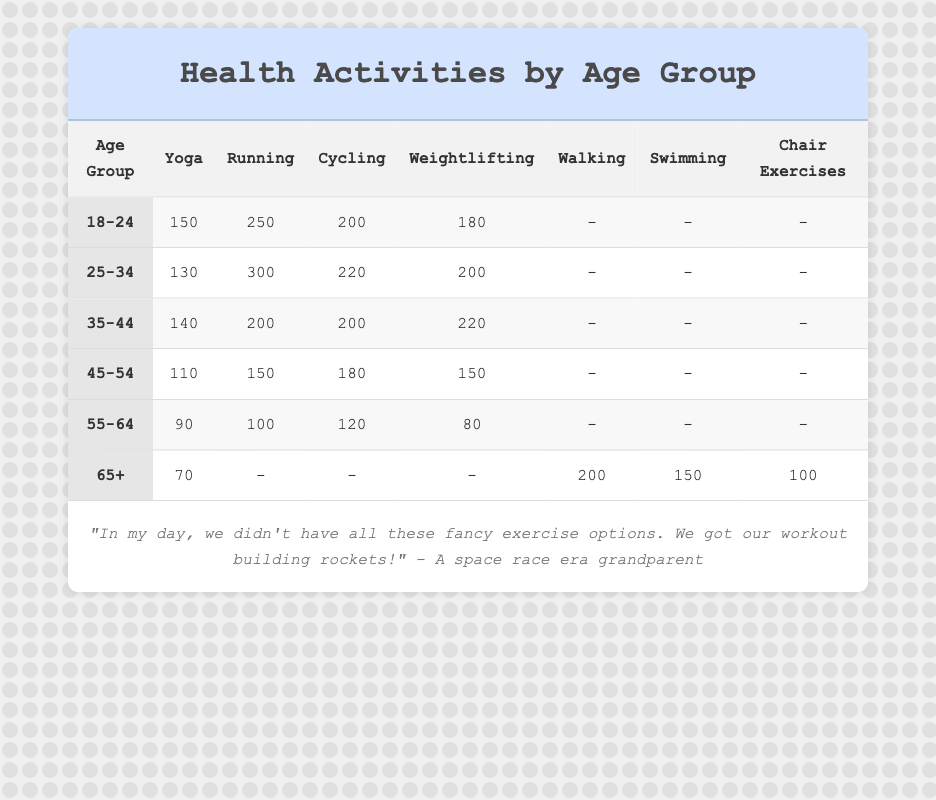What is the preferred exercise type for the age group 25-34? The table shows that the preferred exercise type for the age group 25-34 is Running, with a total of 300 people participating in it.
Answer: Running How many people in the 65+ age group prefer Swimming? From the table, it is clear that the number of people in the 65+ age group who prefer Swimming is 150.
Answer: 150 Which age group has the highest participation in Weightlifting? Examining the Weightlifting column, the age group 35-44 shows the highest participation with 220 individuals.
Answer: 35-44 What is the total number of individuals who prefer Yoga across all age groups? To find the total, we sum the participation in Yoga from all age groups: 150 + 130 + 140 + 110 + 90 + 70 = 690. Thus, the total number of individuals who prefer Yoga is 690.
Answer: 690 Is it true that more people in the age group 55-64 prefer Running than Yoga? In the table, the number of people in the age group 55-64 who prefer Running is 100, while for Yoga it is 90. Therefore, it is true that more people in this age group prefer Running than Yoga.
Answer: Yes What is the difference between the number of individuals who prefer Cycling in the 18-24 and 45-54 age groups? The number of individuals preferring Cycling in the 18-24 age group is 200, while in the 45-54 age group it is 180. The difference is calculated as 200 - 180 = 20. Hence, the difference is 20.
Answer: 20 Which age group has the least participation in Weightlifting and what is the number? Reviewing the Weightlifting column, the age group with the least participation in Weightlifting is 55-64 with a total of 80.
Answer: 55-64, 80 What is the average number of people who prefer Walking among those aged 65 and above? In the age group 65+, there is only one value for Walking, which is 200. Since there is only one data point, the average for Walking is also 200.
Answer: 200 Which activity has the highest total participation across all age groups? To determine this, we sum the participation numbers for each activity: Yoga (690), Running (1,100), Cycling (1,020), Weightlifting (960), Walking (200), Swimming (150), and Chair Exercises (100). The highest total is for Running, with 1,100 participants.
Answer: Running 